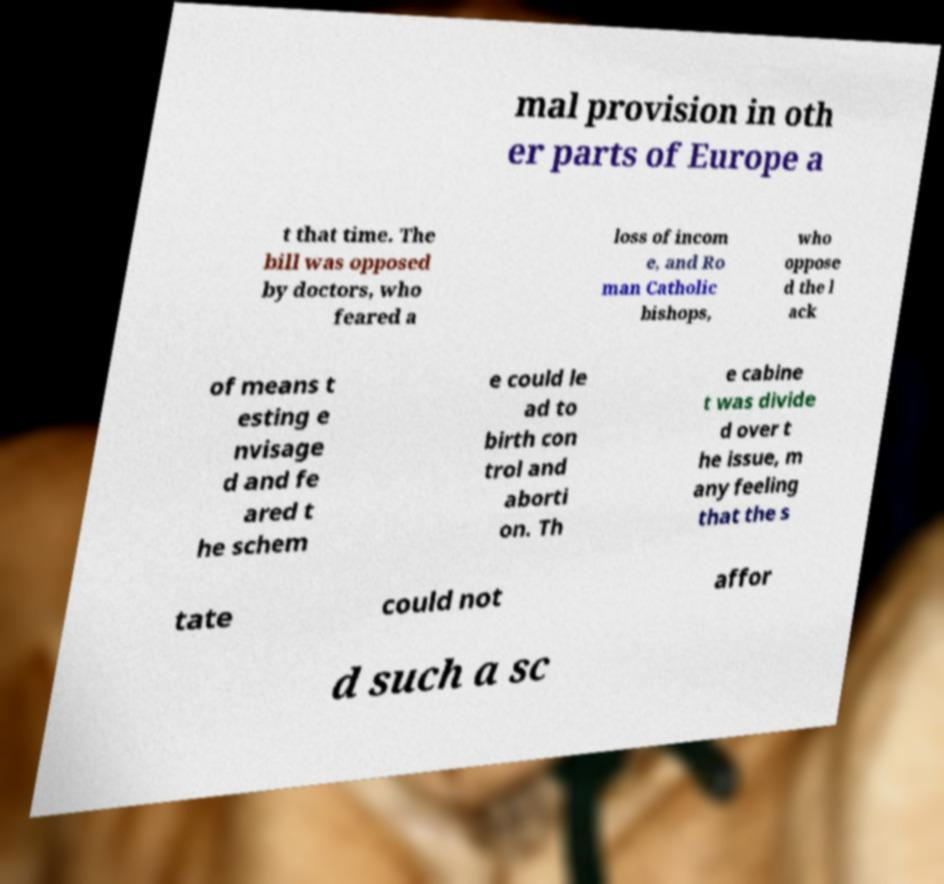Can you read and provide the text displayed in the image?This photo seems to have some interesting text. Can you extract and type it out for me? mal provision in oth er parts of Europe a t that time. The bill was opposed by doctors, who feared a loss of incom e, and Ro man Catholic bishops, who oppose d the l ack of means t esting e nvisage d and fe ared t he schem e could le ad to birth con trol and aborti on. Th e cabine t was divide d over t he issue, m any feeling that the s tate could not affor d such a sc 